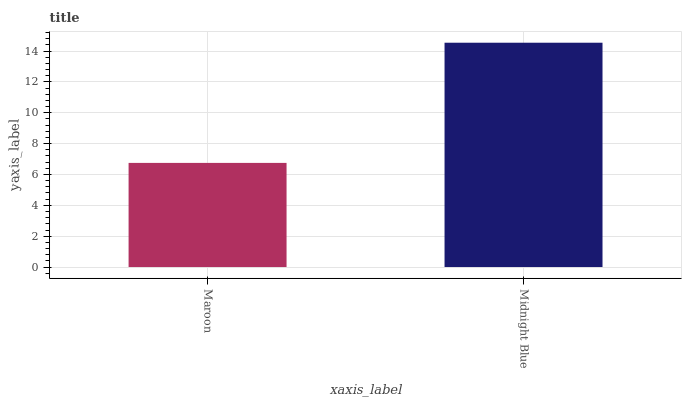Is Maroon the minimum?
Answer yes or no. Yes. Is Midnight Blue the maximum?
Answer yes or no. Yes. Is Midnight Blue the minimum?
Answer yes or no. No. Is Midnight Blue greater than Maroon?
Answer yes or no. Yes. Is Maroon less than Midnight Blue?
Answer yes or no. Yes. Is Maroon greater than Midnight Blue?
Answer yes or no. No. Is Midnight Blue less than Maroon?
Answer yes or no. No. Is Midnight Blue the high median?
Answer yes or no. Yes. Is Maroon the low median?
Answer yes or no. Yes. Is Maroon the high median?
Answer yes or no. No. Is Midnight Blue the low median?
Answer yes or no. No. 